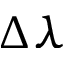Convert formula to latex. <formula><loc_0><loc_0><loc_500><loc_500>\Delta \lambda</formula> 